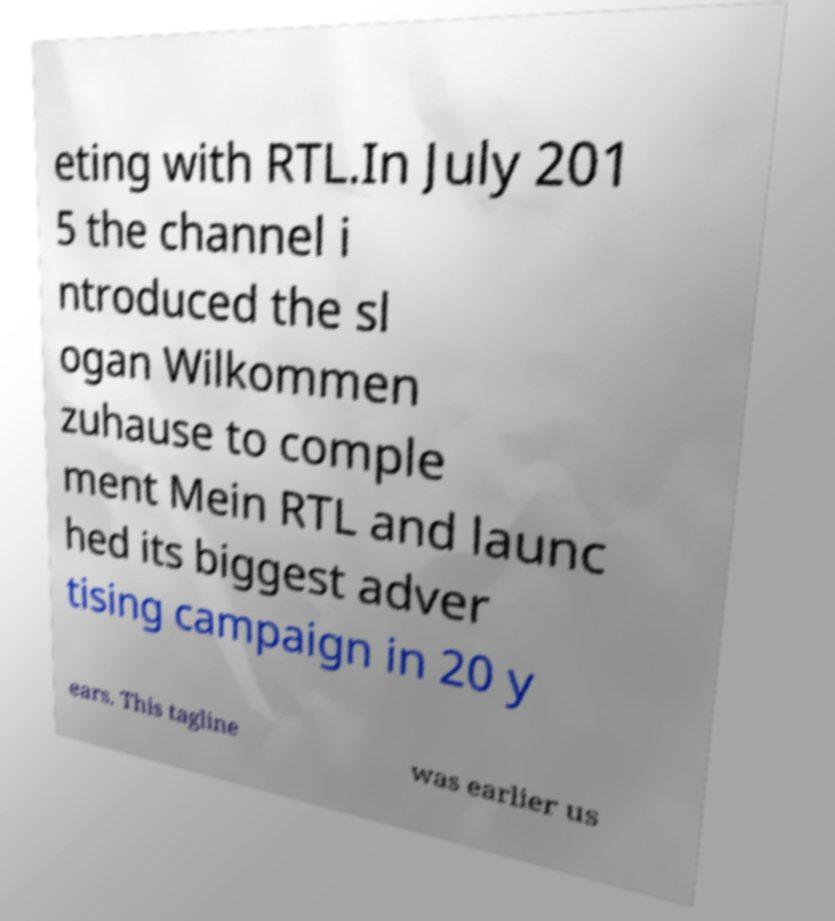Please identify and transcribe the text found in this image. eting with RTL.In July 201 5 the channel i ntroduced the sl ogan Wilkommen zuhause to comple ment Mein RTL and launc hed its biggest adver tising campaign in 20 y ears. This tagline was earlier us 